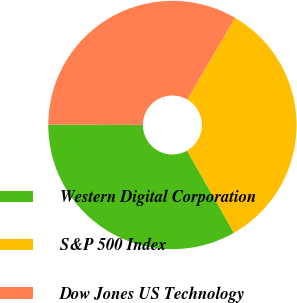<chart> <loc_0><loc_0><loc_500><loc_500><pie_chart><fcel>Western Digital Corporation<fcel>S&P 500 Index<fcel>Dow Jones US Technology<nl><fcel>33.3%<fcel>33.33%<fcel>33.37%<nl></chart> 